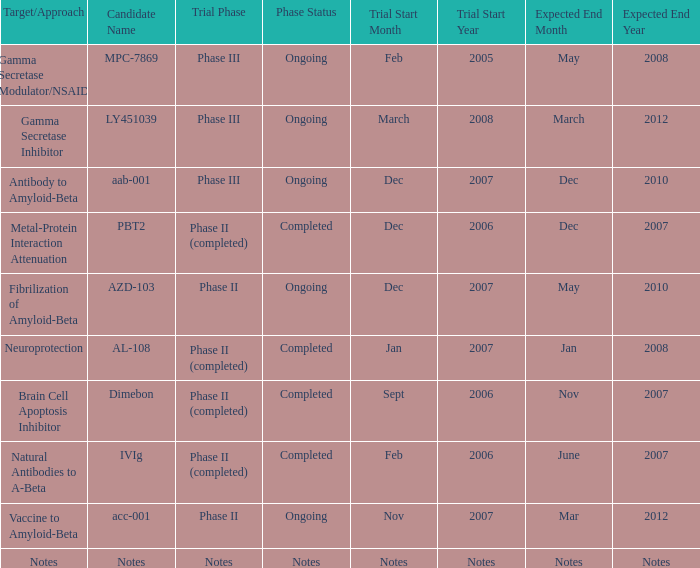What is Trial Start Date, when Candidate Name is PBT2? Dec 2006. 